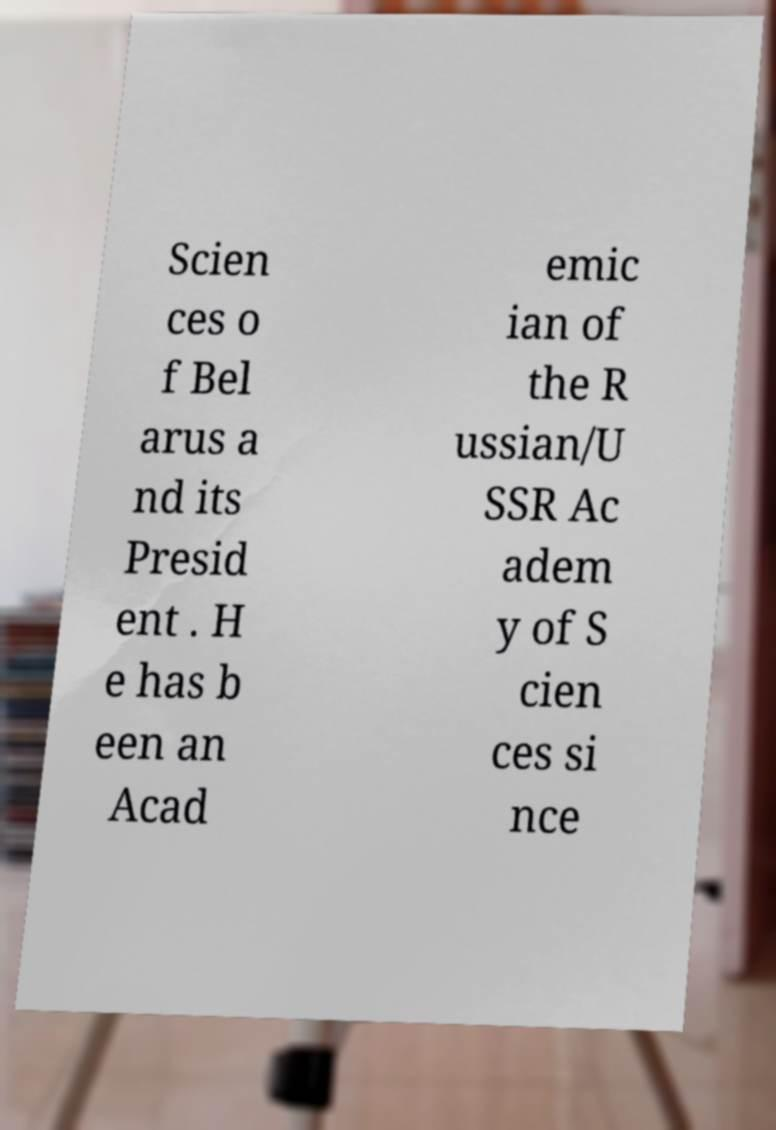Could you extract and type out the text from this image? Scien ces o f Bel arus a nd its Presid ent . H e has b een an Acad emic ian of the R ussian/U SSR Ac adem y of S cien ces si nce 